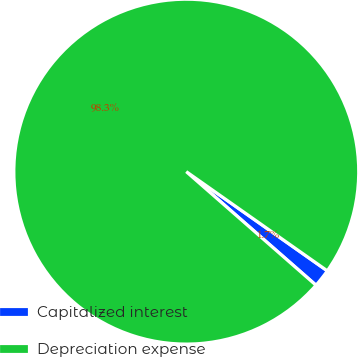Convert chart to OTSL. <chart><loc_0><loc_0><loc_500><loc_500><pie_chart><fcel>Capitalized interest<fcel>Depreciation expense<nl><fcel>1.69%<fcel>98.31%<nl></chart> 